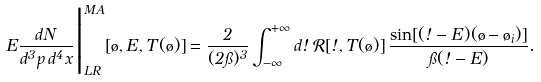<formula> <loc_0><loc_0><loc_500><loc_500>E \frac { d N } { d ^ { 3 } p \, d ^ { 4 } x } \Big | _ { L R } ^ { M A } [ \tau , E , T ( \tau ) ] = \frac { 2 } { ( 2 \pi ) ^ { 3 } } \int _ { - \infty } ^ { + \infty } d \omega \, \mathcal { R } [ \omega , T ( \tau ) ] \, \frac { \sin [ ( \omega - E ) ( \tau - \tau _ { i } ) ] } { \pi ( \omega - E ) } .</formula> 